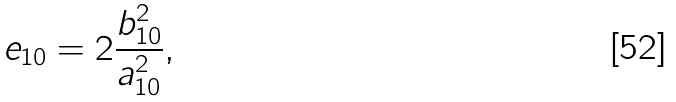<formula> <loc_0><loc_0><loc_500><loc_500>e _ { 1 0 } = 2 \frac { b _ { 1 0 } ^ { 2 } } { a _ { 1 0 } ^ { 2 } } ,</formula> 